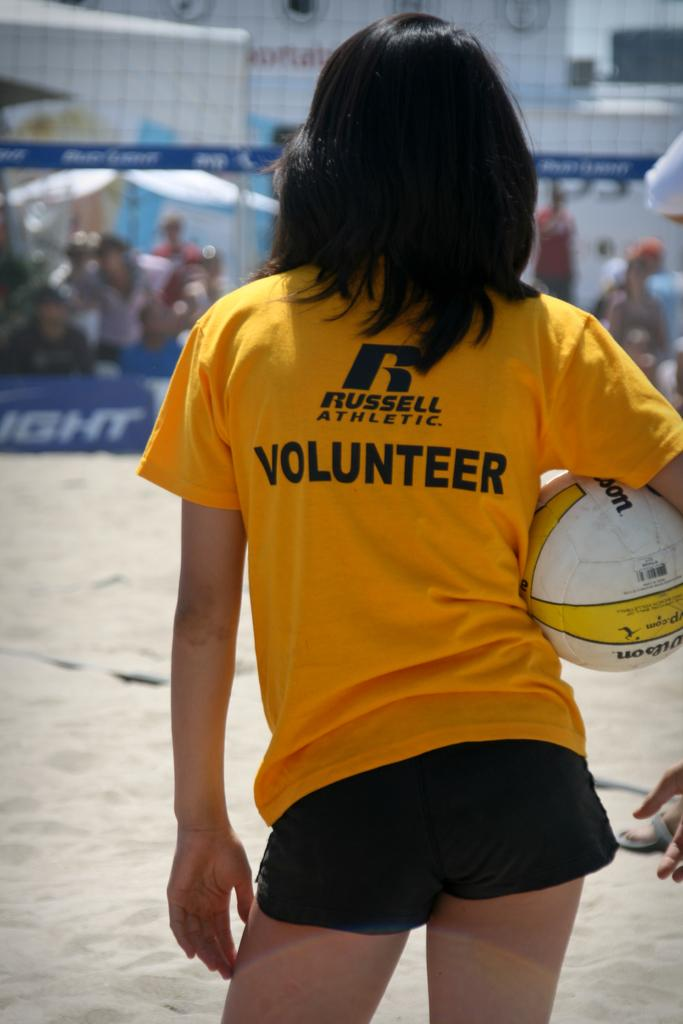What is the person in the image doing? The person is standing in the image and holding a ball. Can you describe the people in the background of the image? There are people visible in the background of the image, but no specific details are provided about them. What type of salt is being stored in the crate in the image? There is no crate or salt present in the image. How many tin cans are visible in the image? There is no tin or tin cans present in the image. 